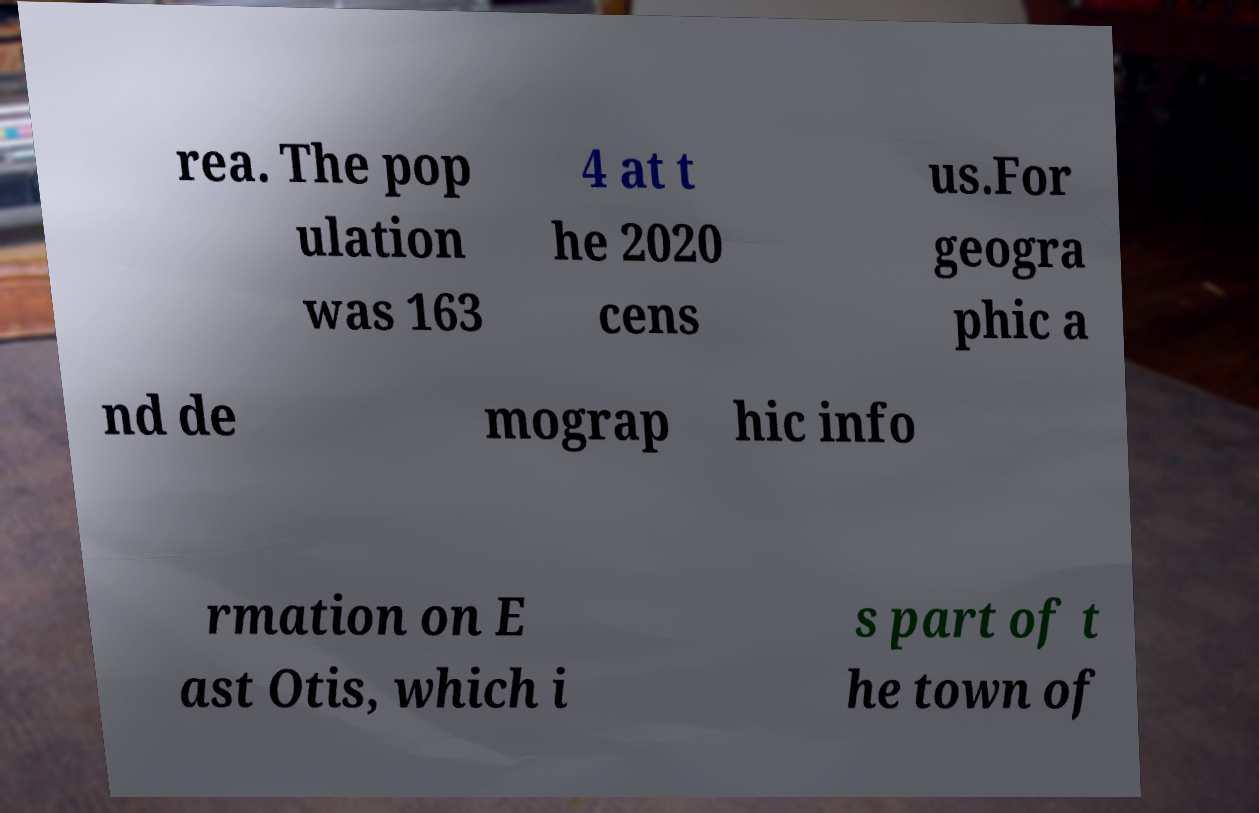Could you assist in decoding the text presented in this image and type it out clearly? rea. The pop ulation was 163 4 at t he 2020 cens us.For geogra phic a nd de mograp hic info rmation on E ast Otis, which i s part of t he town of 